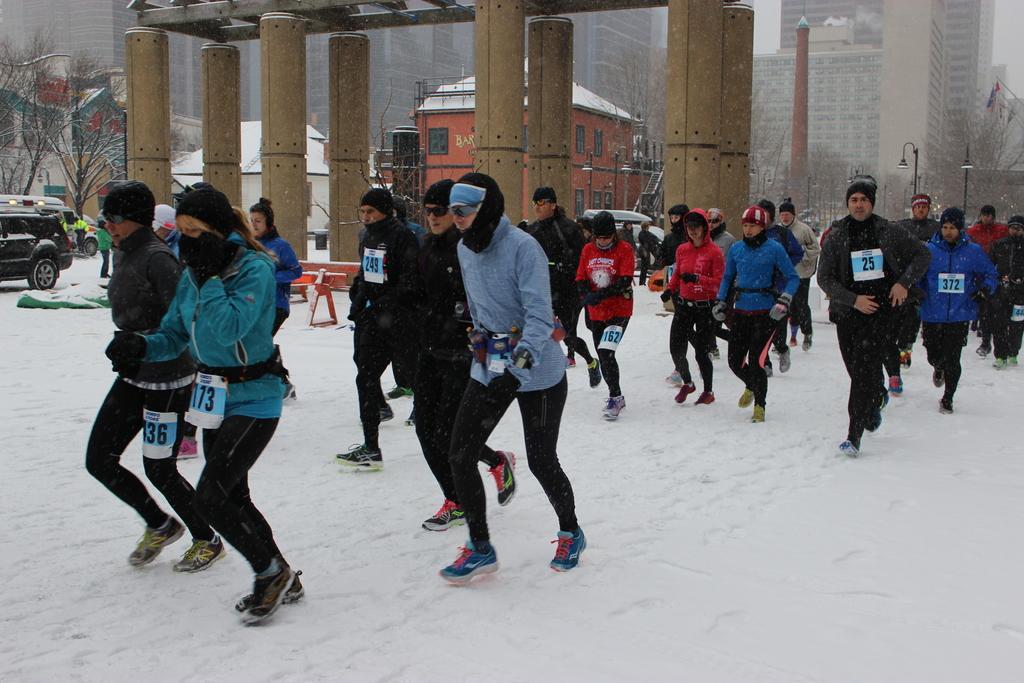In one or two sentences, can you explain what this image depicts? In this image we can see many persons running on the snow. In the background we can see pillars, trees, house, buildings and sky. 